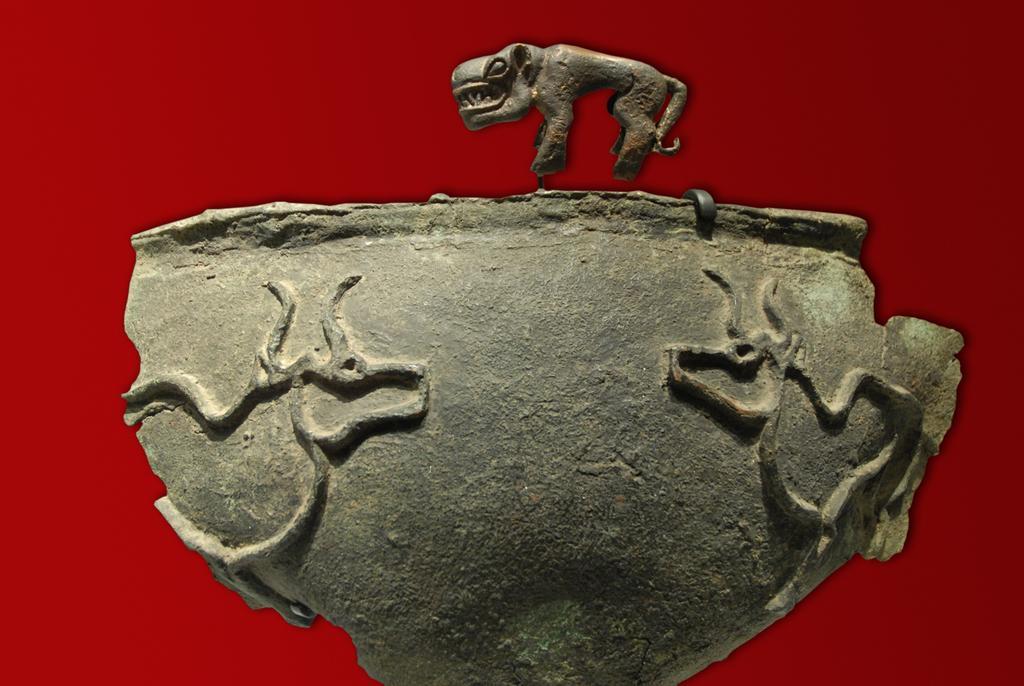How would you summarize this image in a sentence or two? In this image we can see the sculpture. 